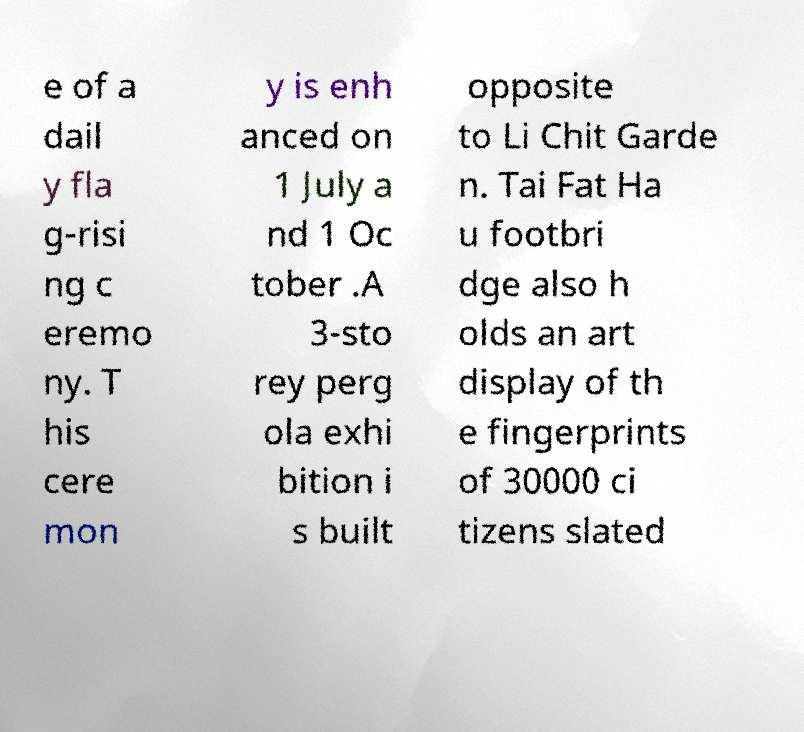I need the written content from this picture converted into text. Can you do that? e of a dail y fla g-risi ng c eremo ny. T his cere mon y is enh anced on 1 July a nd 1 Oc tober .A 3-sto rey perg ola exhi bition i s built opposite to Li Chit Garde n. Tai Fat Ha u footbri dge also h olds an art display of th e fingerprints of 30000 ci tizens slated 